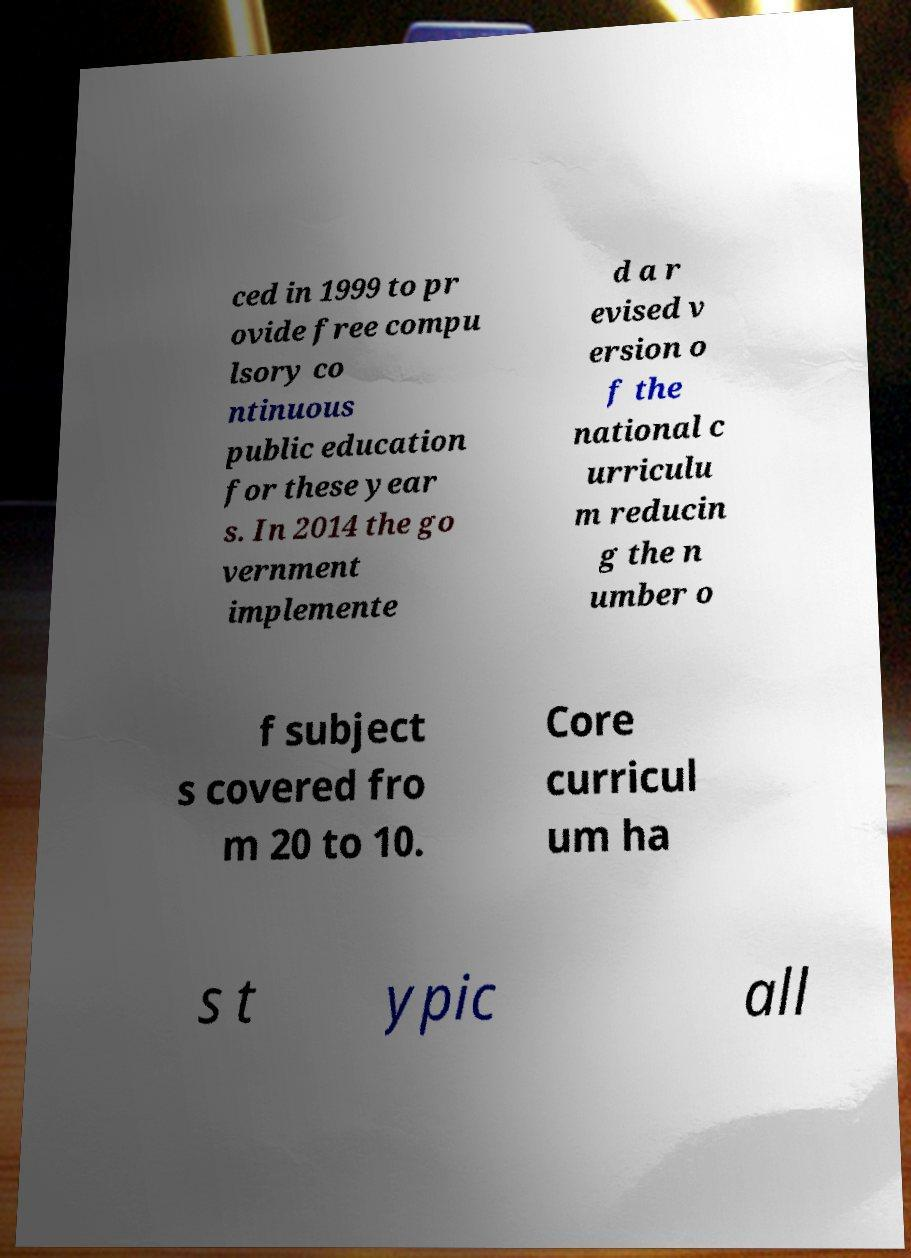Can you read and provide the text displayed in the image?This photo seems to have some interesting text. Can you extract and type it out for me? ced in 1999 to pr ovide free compu lsory co ntinuous public education for these year s. In 2014 the go vernment implemente d a r evised v ersion o f the national c urriculu m reducin g the n umber o f subject s covered fro m 20 to 10. Core curricul um ha s t ypic all 